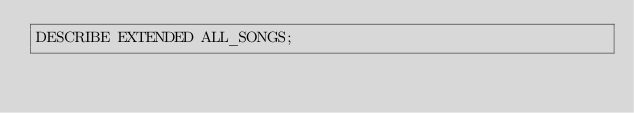Convert code to text. <code><loc_0><loc_0><loc_500><loc_500><_SQL_>DESCRIBE EXTENDED ALL_SONGS;
</code> 